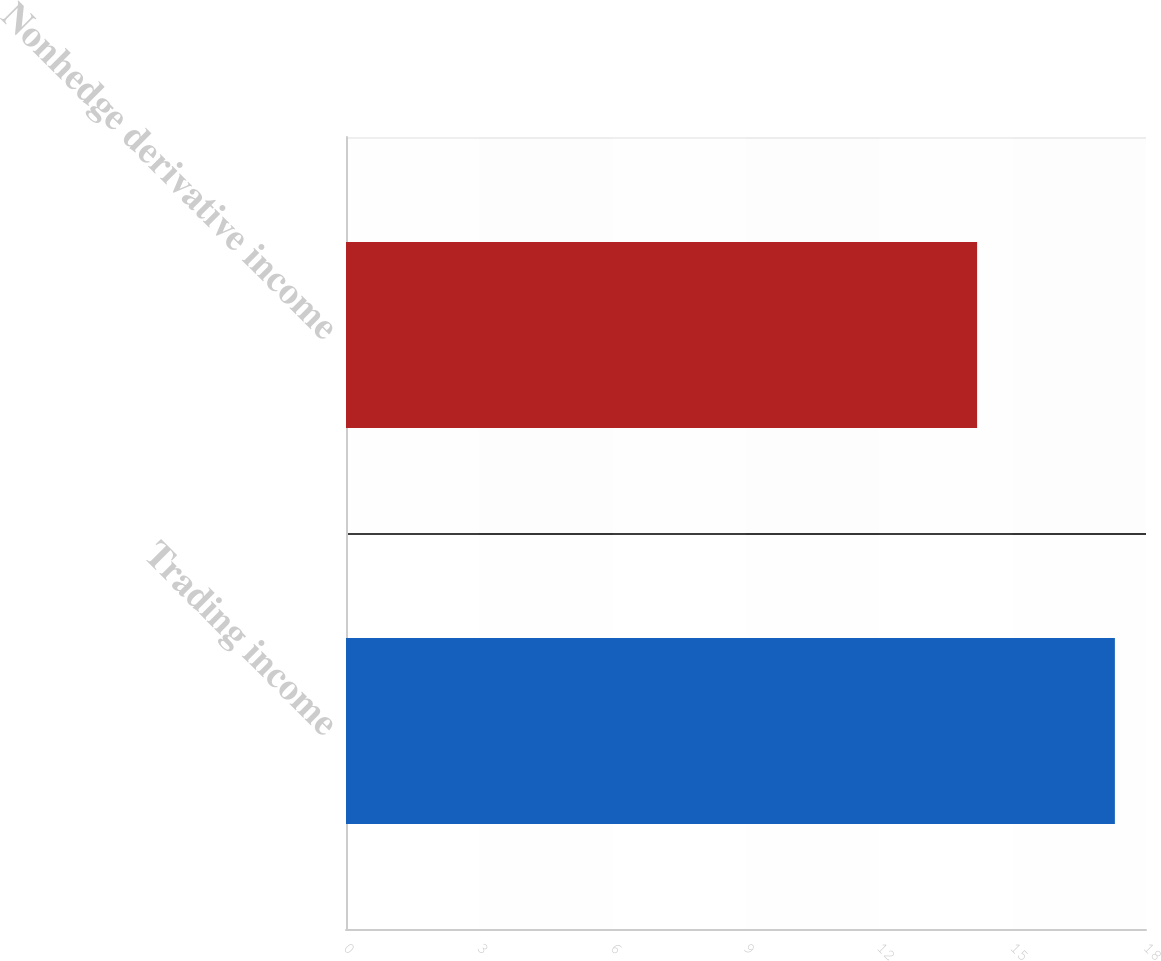Convert chart to OTSL. <chart><loc_0><loc_0><loc_500><loc_500><bar_chart><fcel>Trading income<fcel>Nonhedge derivative income<nl><fcel>17.3<fcel>14.2<nl></chart> 